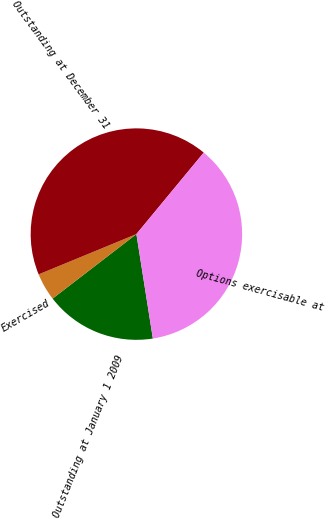Convert chart. <chart><loc_0><loc_0><loc_500><loc_500><pie_chart><fcel>Outstanding at January 1 2009<fcel>Exercised<fcel>Outstanding at December 31<fcel>Options exercisable at<nl><fcel>17.05%<fcel>4.22%<fcel>42.21%<fcel>36.52%<nl></chart> 